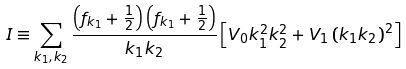Convert formula to latex. <formula><loc_0><loc_0><loc_500><loc_500>I \equiv \sum _ { k _ { 1 } , k _ { 2 } } \frac { \left ( f _ { k _ { 1 } } + \frac { 1 } { 2 } \right ) \left ( f _ { k _ { 1 } } + \frac { 1 } { 2 } \right ) } { k _ { 1 } k _ { 2 } } \left [ V _ { 0 } k _ { 1 } ^ { 2 } k _ { 2 } ^ { 2 } + V _ { 1 } \left ( k _ { 1 } k _ { 2 } \right ) ^ { 2 } \right ]</formula> 